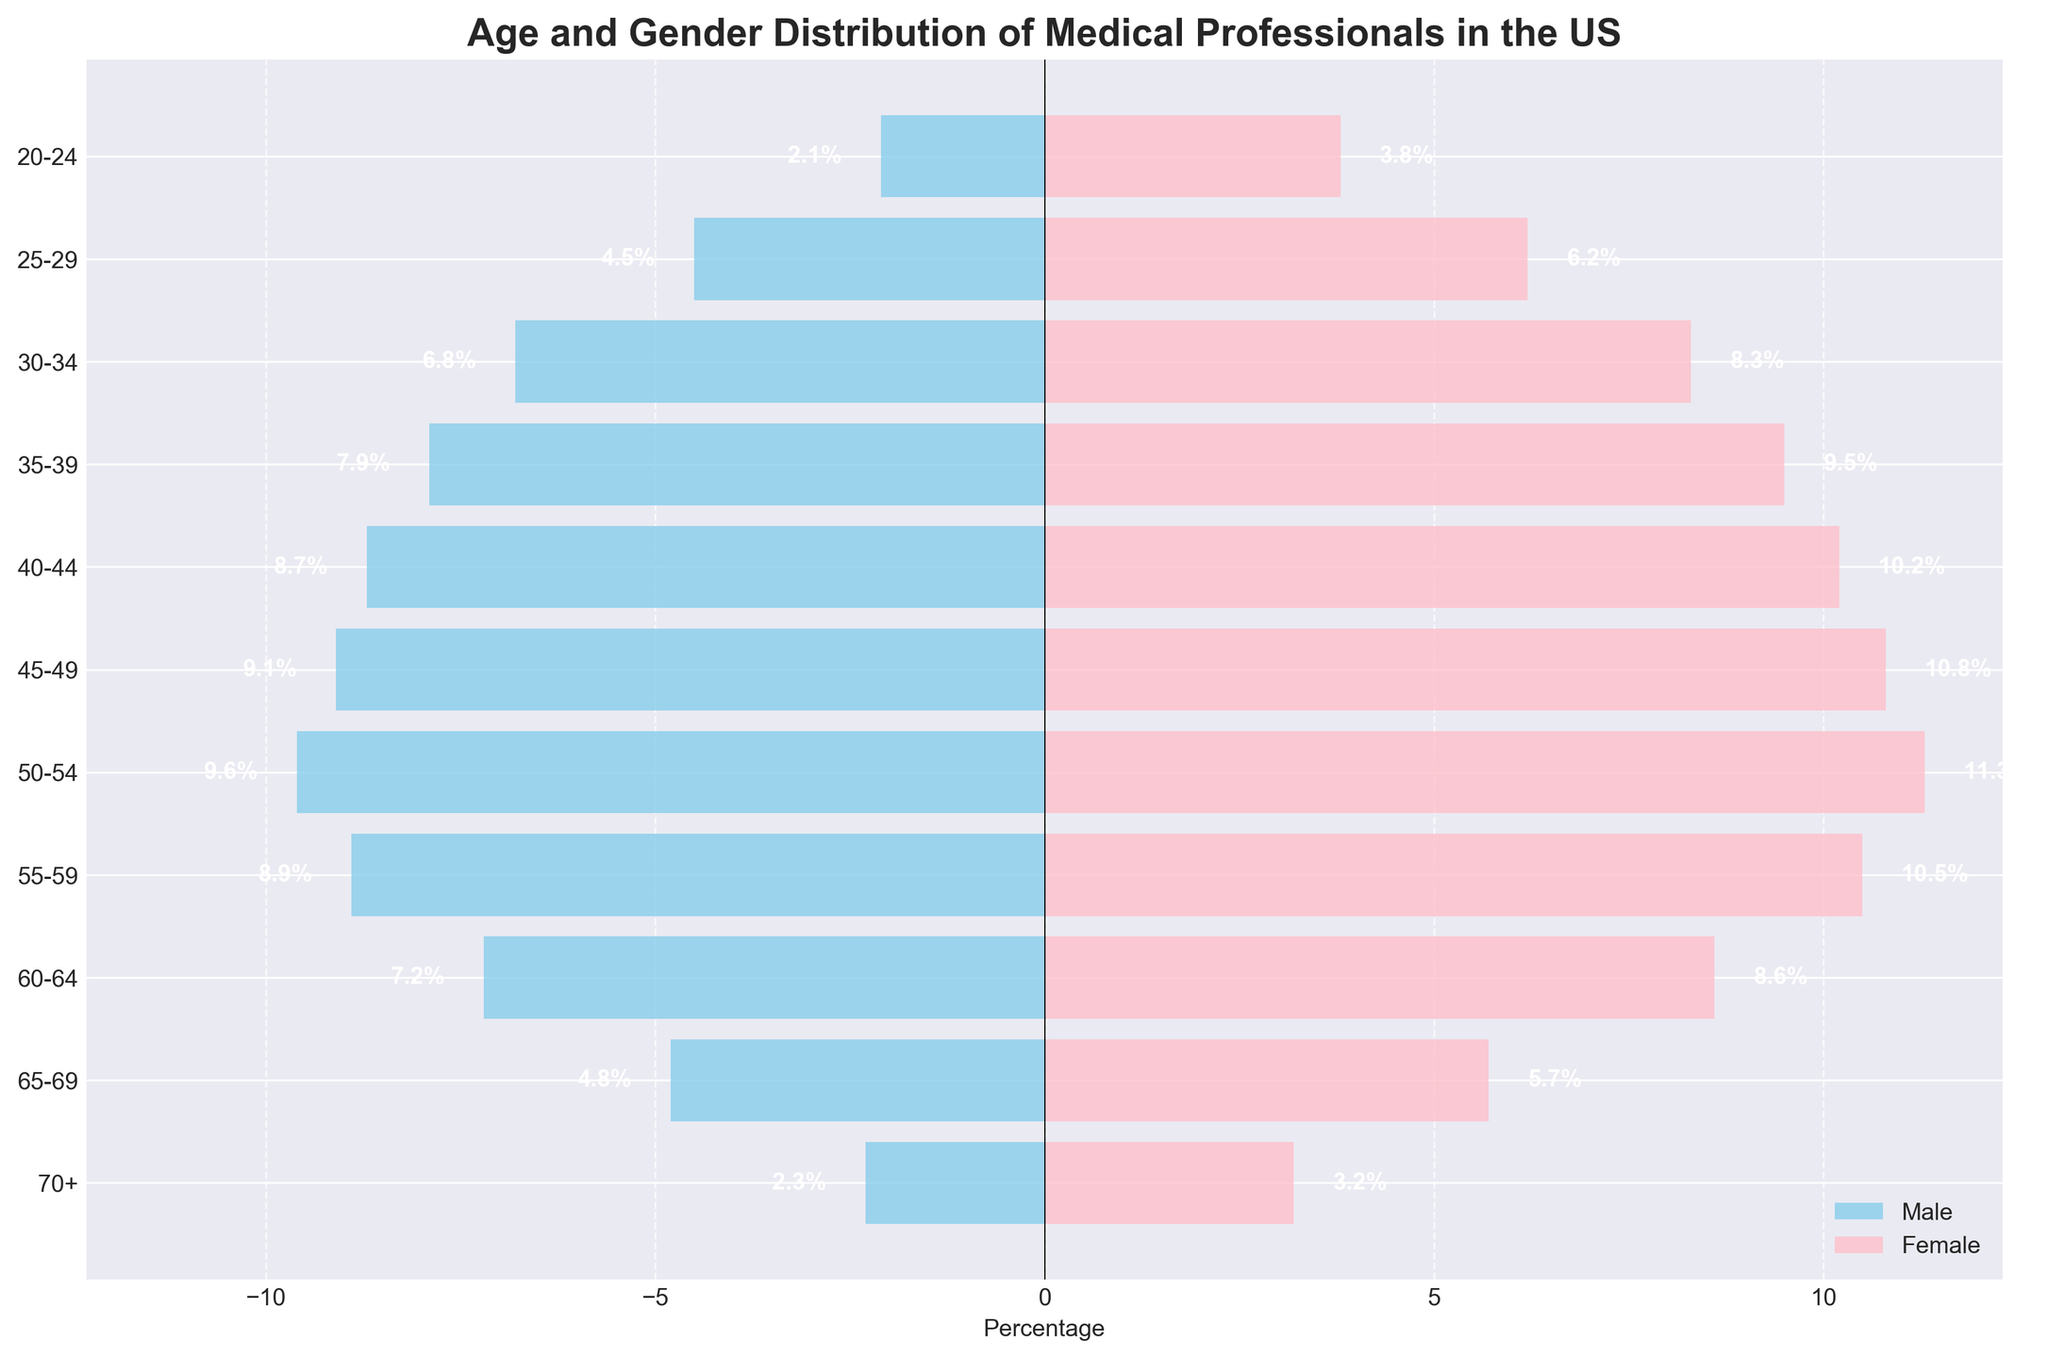What is the title of the plot? The title is located at the top of the plot and is usually the largest text. It is "Age and Gender Distribution of Medical Professionals in the US".
Answer: Age and Gender Distribution of Medical Professionals in the US What age group has the highest percentage of female medical professionals? Look at the bars representing females (in pink) and identify the age group with the longest bar. The age group 50-54 has the longest pink bar for females.
Answer: 50-54 Which gender has a higher percentage in the 30-34 age group? Compare the lengths of the bars for males and females in the 30-34 age group. The pink bar (females) is longer than the blue bar (males).
Answer: Female How much greater is the percentage of female medical professionals aged 45-49 compared to males in the same age group? Identify the lengths of the bars for males (9.1%) and females (10.8%) in the 45-49 age group. Calculate the difference: 10.8% - 9.1% = 1.7%.
Answer: 1.7% What is the most significant age group difference in gender percentages? Compare the male and female percentages for each age group and find the one with the largest difference. The 50-54 age group has male 9.6% and female 11.3%, resulting in a difference of 1.7%.
Answer: 50-54 In which age group do the percentages of male and female medical professionals most closely align? Calculate the absolute difference between male and female percentages for each age group. The group with the smallest difference is the 55-59 age group (8.9% males, 10.5% females), with a difference of 1.6%.
Answer: 55-59 What trend do you observe in the percentage of male medical professionals as age increases? Observe the pattern of the blue bars representing males from the youngest to the oldest age group. The percentage peaks at the 50-54 age group and generally decreases after that.
Answer: Decreasing trend after peaking at 50-54 What is the total percentage of medical professionals aged 20-24? Add the male percentage (2.1%) and the female percentage (3.8%) in the 20-24 age group: 2.1% + 3.8% = 5.9%.
Answer: 5.9% Which age group has the lowest combined percentage of medical professionals? Find the age group with the smallest sum of male and female percentages. The 70+ age group has the combined percentage of 2.3% males and 3.2% females, totaling 5.5%.
Answer: 70+ How does the percentage of female medical professionals change from ages 30-34 to 40-44? Note the female percentages in the 30-34 (8.3%) and 40-44 (10.2%) age groups, and calculate the difference: 10.2% - 8.3% = 1.9%.
Answer: Increases by 1.9% 